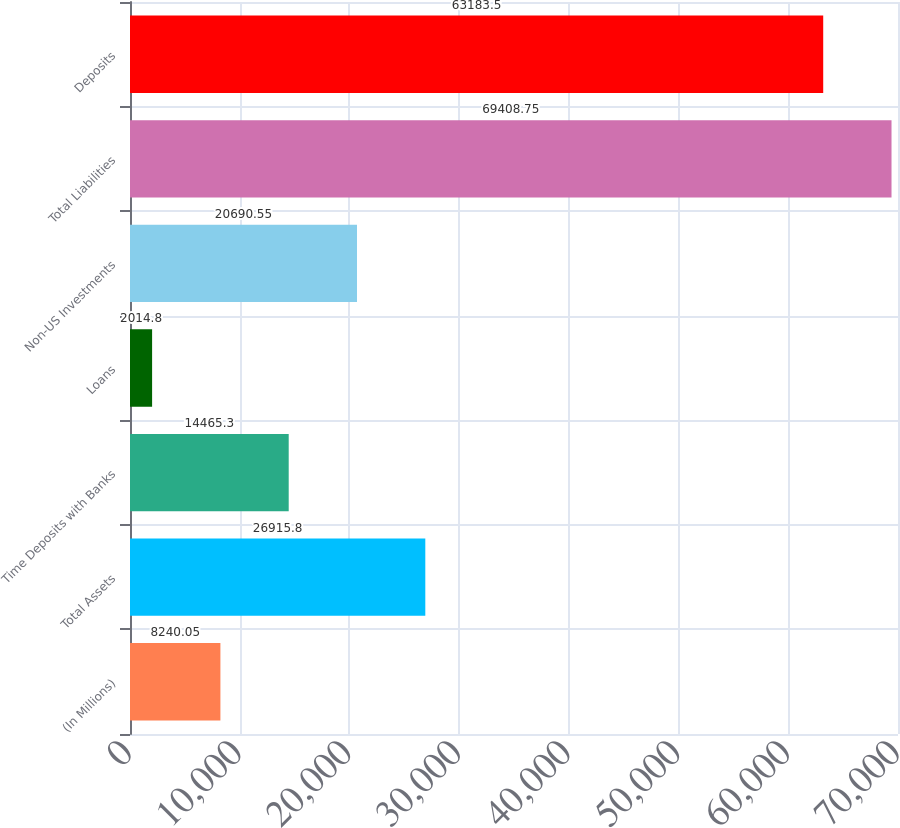Convert chart to OTSL. <chart><loc_0><loc_0><loc_500><loc_500><bar_chart><fcel>(In Millions)<fcel>Total Assets<fcel>Time Deposits with Banks<fcel>Loans<fcel>Non-US Investments<fcel>Total Liabilities<fcel>Deposits<nl><fcel>8240.05<fcel>26915.8<fcel>14465.3<fcel>2014.8<fcel>20690.5<fcel>69408.8<fcel>63183.5<nl></chart> 